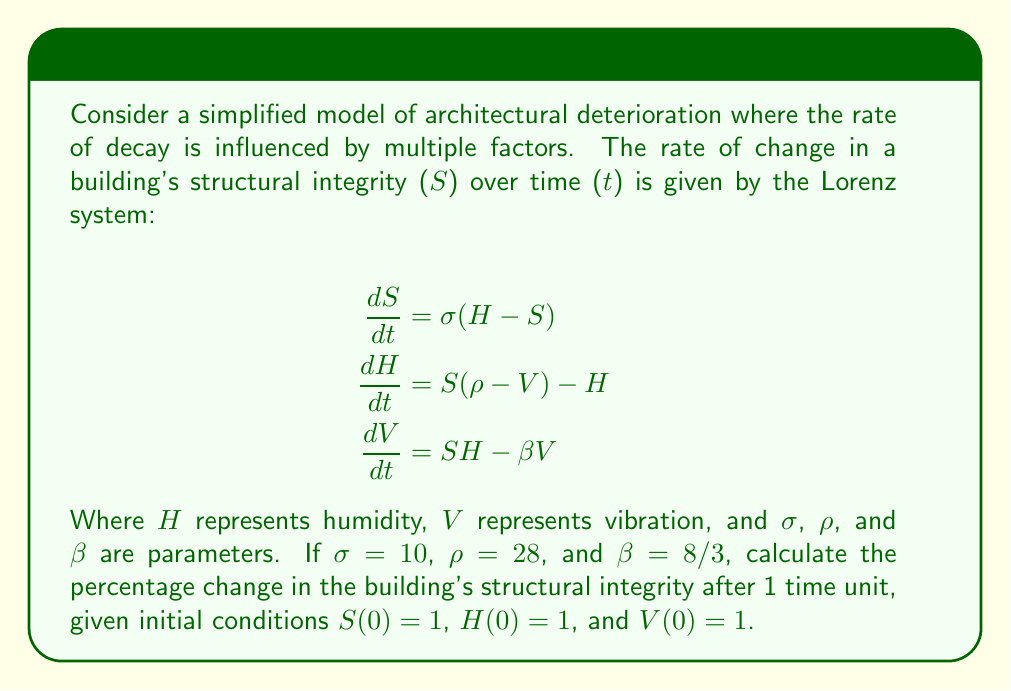Can you solve this math problem? To solve this problem, we need to use numerical methods as the Lorenz system doesn't have a general analytical solution. We'll use the fourth-order Runge-Kutta method (RK4) to approximate the solution.

Step 1: Define the system of equations
Let f1, f2, and f3 represent the right-hand sides of the Lorenz equations:
$$f_1(S,H,V) = \sigma(H - S)$$
$$f_2(S,H,V) = S(\rho - V) - H$$
$$f_3(S,H,V) = SH - \beta V$$

Step 2: Implement RK4 method
For a small time step h, we calculate:
$$k_1 = hf(t_n, y_n)$$
$$k_2 = hf(t_n + \frac{h}{2}, y_n + \frac{k_1}{2})$$
$$k_3 = hf(t_n + \frac{h}{2}, y_n + \frac{k_2}{2})$$
$$k_4 = hf(t_n + h, y_n + k_3)$$
$$y_{n+1} = y_n + \frac{1}{6}(k_1 + 2k_2 + 2k_3 + k_4)$$

Step 3: Apply RK4 to our system
Let's use h = 0.01 and perform 100 iterations to reach t = 1.

Initial conditions: S = 1, H = 1, V = 1
Parameters: σ = 10, ρ = 28, β = 8/3

After 100 iterations:
S ≈ 13.8019
H ≈ 19.5935
V ≈ 25.5135

Step 4: Calculate percentage change
Percentage change in S = (S_final - S_initial) / S_initial * 100
                       = (13.8019 - 1) / 1 * 100
                       ≈ 1280.19%
Answer: 1280.19% 